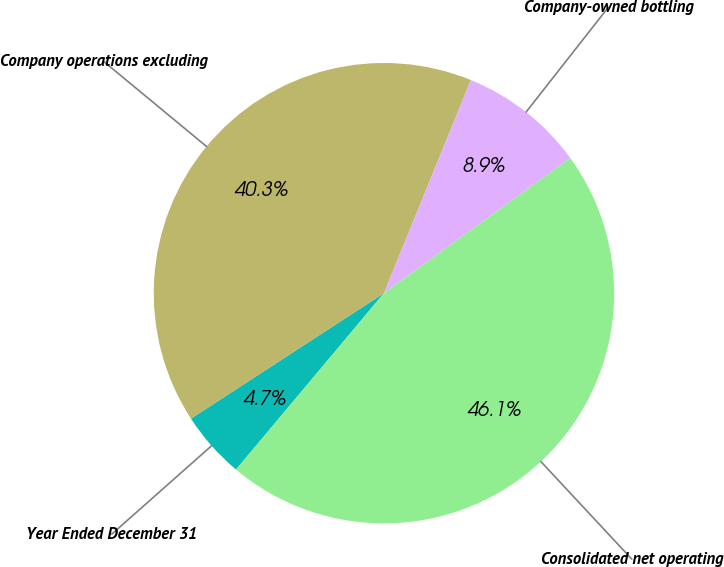Convert chart to OTSL. <chart><loc_0><loc_0><loc_500><loc_500><pie_chart><fcel>Year Ended December 31<fcel>Company operations excluding<fcel>Company-owned bottling<fcel>Consolidated net operating<nl><fcel>4.72%<fcel>40.34%<fcel>8.85%<fcel>46.09%<nl></chart> 